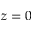Convert formula to latex. <formula><loc_0><loc_0><loc_500><loc_500>z = 0</formula> 